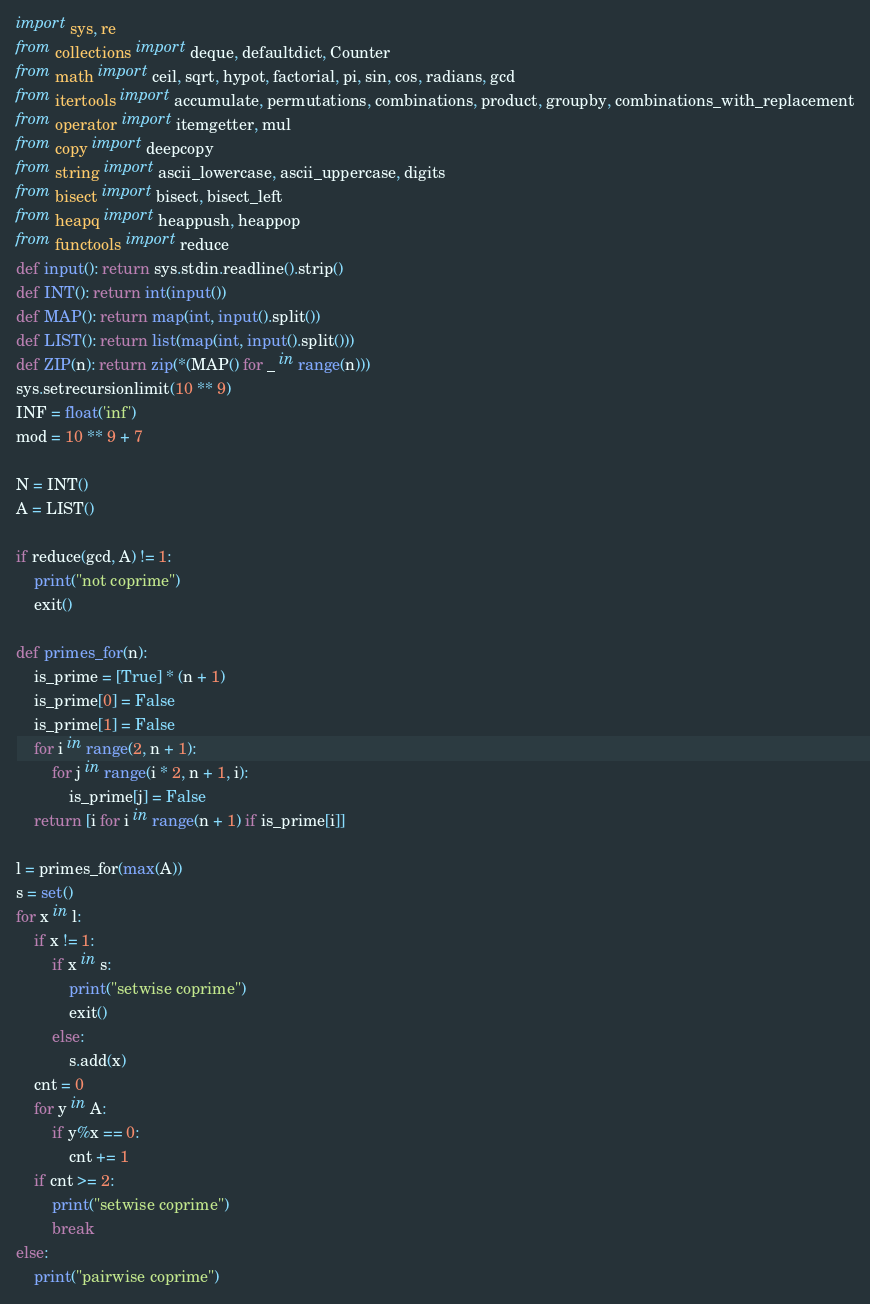<code> <loc_0><loc_0><loc_500><loc_500><_Python_>import sys, re
from collections import deque, defaultdict, Counter
from math import ceil, sqrt, hypot, factorial, pi, sin, cos, radians, gcd
from itertools import accumulate, permutations, combinations, product, groupby, combinations_with_replacement
from operator import itemgetter, mul
from copy import deepcopy
from string import ascii_lowercase, ascii_uppercase, digits
from bisect import bisect, bisect_left
from heapq import heappush, heappop
from functools import reduce
def input(): return sys.stdin.readline().strip()
def INT(): return int(input())
def MAP(): return map(int, input().split())
def LIST(): return list(map(int, input().split()))
def ZIP(n): return zip(*(MAP() for _ in range(n)))
sys.setrecursionlimit(10 ** 9)
INF = float('inf')
mod = 10 ** 9 + 7

N = INT()
A = LIST()

if reduce(gcd, A) != 1:
    print("not coprime")
    exit()

def primes_for(n):
    is_prime = [True] * (n + 1)
    is_prime[0] = False
    is_prime[1] = False
    for i in range(2, n + 1):
        for j in range(i * 2, n + 1, i):
            is_prime[j] = False
    return [i for i in range(n + 1) if is_prime[i]]

l = primes_for(max(A))
s = set()
for x in l:
    if x != 1:
        if x in s:
            print("setwise coprime")
            exit()
        else:
            s.add(x)
    cnt = 0
    for y in A:
        if y%x == 0:
            cnt += 1
    if cnt >= 2:
        print("setwise coprime")
        break
else:
    print("pairwise coprime")
</code> 